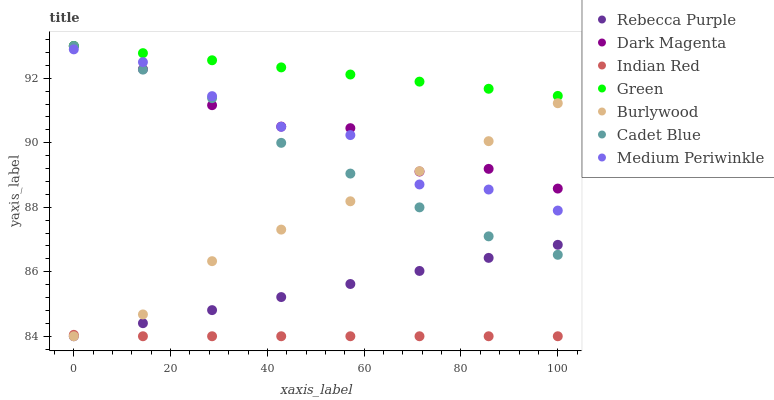Does Indian Red have the minimum area under the curve?
Answer yes or no. Yes. Does Green have the maximum area under the curve?
Answer yes or no. Yes. Does Dark Magenta have the minimum area under the curve?
Answer yes or no. No. Does Dark Magenta have the maximum area under the curve?
Answer yes or no. No. Is Green the smoothest?
Answer yes or no. Yes. Is Dark Magenta the roughest?
Answer yes or no. Yes. Is Burlywood the smoothest?
Answer yes or no. No. Is Burlywood the roughest?
Answer yes or no. No. Does Burlywood have the lowest value?
Answer yes or no. Yes. Does Dark Magenta have the lowest value?
Answer yes or no. No. Does Green have the highest value?
Answer yes or no. Yes. Does Burlywood have the highest value?
Answer yes or no. No. Is Indian Red less than Dark Magenta?
Answer yes or no. Yes. Is Green greater than Burlywood?
Answer yes or no. Yes. Does Indian Red intersect Rebecca Purple?
Answer yes or no. Yes. Is Indian Red less than Rebecca Purple?
Answer yes or no. No. Is Indian Red greater than Rebecca Purple?
Answer yes or no. No. Does Indian Red intersect Dark Magenta?
Answer yes or no. No. 